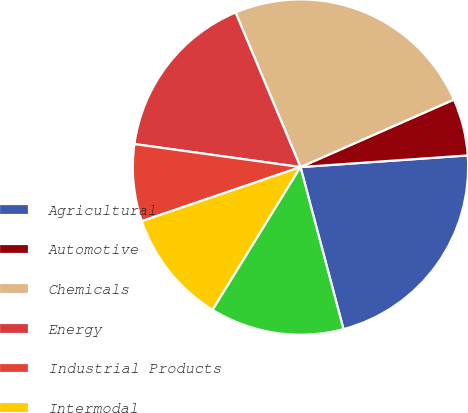Convert chart to OTSL. <chart><loc_0><loc_0><loc_500><loc_500><pie_chart><fcel>Agricultural<fcel>Automotive<fcel>Chemicals<fcel>Energy<fcel>Industrial Products<fcel>Intermodal<fcel>Total<nl><fcel>21.98%<fcel>5.49%<fcel>24.73%<fcel>16.48%<fcel>7.42%<fcel>10.99%<fcel>12.91%<nl></chart> 